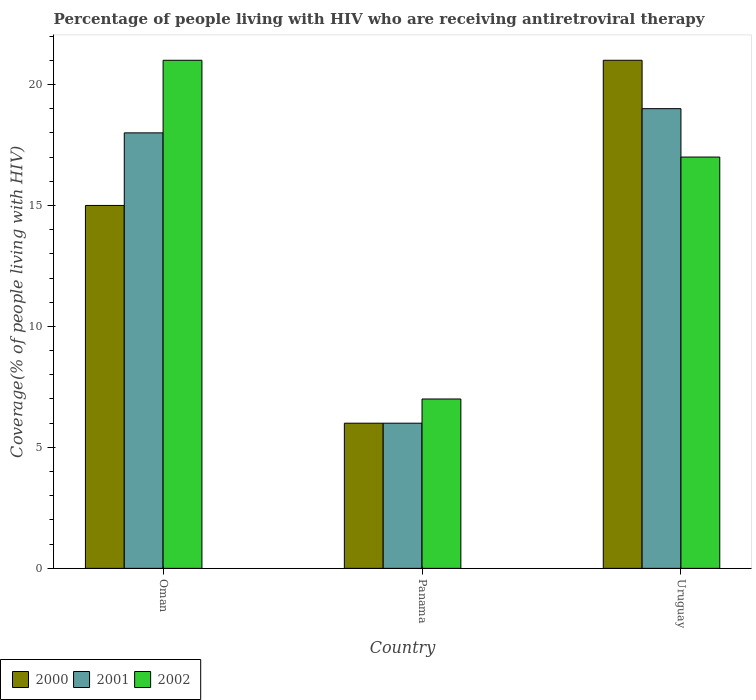Are the number of bars per tick equal to the number of legend labels?
Your response must be concise. Yes. How many bars are there on the 3rd tick from the left?
Offer a terse response. 3. What is the label of the 1st group of bars from the left?
Provide a succinct answer. Oman. In how many cases, is the number of bars for a given country not equal to the number of legend labels?
Your response must be concise. 0. Across all countries, what is the maximum percentage of the HIV infected people who are receiving antiretroviral therapy in 2000?
Offer a very short reply. 21. In which country was the percentage of the HIV infected people who are receiving antiretroviral therapy in 2000 maximum?
Your answer should be very brief. Uruguay. In which country was the percentage of the HIV infected people who are receiving antiretroviral therapy in 2000 minimum?
Offer a very short reply. Panama. What is the difference between the percentage of the HIV infected people who are receiving antiretroviral therapy in 2001 in Uruguay and the percentage of the HIV infected people who are receiving antiretroviral therapy in 2000 in Panama?
Give a very brief answer. 13. What is the average percentage of the HIV infected people who are receiving antiretroviral therapy in 2001 per country?
Give a very brief answer. 14.33. What is the ratio of the percentage of the HIV infected people who are receiving antiretroviral therapy in 2002 in Panama to that in Uruguay?
Offer a terse response. 0.41. Is the percentage of the HIV infected people who are receiving antiretroviral therapy in 2001 in Oman less than that in Panama?
Provide a succinct answer. No. Is the difference between the percentage of the HIV infected people who are receiving antiretroviral therapy in 2001 in Oman and Uruguay greater than the difference between the percentage of the HIV infected people who are receiving antiretroviral therapy in 2000 in Oman and Uruguay?
Offer a very short reply. Yes. What is the difference between the highest and the second highest percentage of the HIV infected people who are receiving antiretroviral therapy in 2001?
Provide a succinct answer. -1. What is the difference between the highest and the lowest percentage of the HIV infected people who are receiving antiretroviral therapy in 2001?
Offer a terse response. 13. In how many countries, is the percentage of the HIV infected people who are receiving antiretroviral therapy in 2000 greater than the average percentage of the HIV infected people who are receiving antiretroviral therapy in 2000 taken over all countries?
Offer a very short reply. 2. Is the sum of the percentage of the HIV infected people who are receiving antiretroviral therapy in 2002 in Oman and Panama greater than the maximum percentage of the HIV infected people who are receiving antiretroviral therapy in 2001 across all countries?
Your answer should be very brief. Yes. What does the 2nd bar from the left in Uruguay represents?
Your answer should be compact. 2001. Are all the bars in the graph horizontal?
Provide a succinct answer. No. How many countries are there in the graph?
Your answer should be very brief. 3. Does the graph contain any zero values?
Offer a very short reply. No. Does the graph contain grids?
Your response must be concise. No. How many legend labels are there?
Give a very brief answer. 3. What is the title of the graph?
Keep it short and to the point. Percentage of people living with HIV who are receiving antiretroviral therapy. What is the label or title of the Y-axis?
Your response must be concise. Coverage(% of people living with HIV). What is the Coverage(% of people living with HIV) of 2000 in Oman?
Ensure brevity in your answer.  15. What is the Coverage(% of people living with HIV) of 2002 in Oman?
Give a very brief answer. 21. What is the Coverage(% of people living with HIV) of 2002 in Panama?
Give a very brief answer. 7. What is the Coverage(% of people living with HIV) of 2002 in Uruguay?
Keep it short and to the point. 17. Across all countries, what is the maximum Coverage(% of people living with HIV) in 2001?
Offer a very short reply. 19. Across all countries, what is the minimum Coverage(% of people living with HIV) of 2002?
Keep it short and to the point. 7. What is the total Coverage(% of people living with HIV) in 2002 in the graph?
Provide a succinct answer. 45. What is the difference between the Coverage(% of people living with HIV) of 2000 in Oman and that in Panama?
Your response must be concise. 9. What is the difference between the Coverage(% of people living with HIV) of 2001 in Oman and that in Panama?
Give a very brief answer. 12. What is the difference between the Coverage(% of people living with HIV) of 2000 in Oman and that in Uruguay?
Make the answer very short. -6. What is the difference between the Coverage(% of people living with HIV) of 2002 in Oman and that in Uruguay?
Provide a succinct answer. 4. What is the difference between the Coverage(% of people living with HIV) in 2000 in Panama and that in Uruguay?
Provide a succinct answer. -15. What is the difference between the Coverage(% of people living with HIV) of 2001 in Panama and that in Uruguay?
Ensure brevity in your answer.  -13. What is the difference between the Coverage(% of people living with HIV) in 2000 in Oman and the Coverage(% of people living with HIV) in 2001 in Panama?
Give a very brief answer. 9. What is the difference between the Coverage(% of people living with HIV) of 2000 in Oman and the Coverage(% of people living with HIV) of 2002 in Panama?
Your answer should be very brief. 8. What is the difference between the Coverage(% of people living with HIV) of 2001 in Oman and the Coverage(% of people living with HIV) of 2002 in Panama?
Provide a short and direct response. 11. What is the difference between the Coverage(% of people living with HIV) of 2000 in Panama and the Coverage(% of people living with HIV) of 2001 in Uruguay?
Keep it short and to the point. -13. What is the difference between the Coverage(% of people living with HIV) in 2000 in Panama and the Coverage(% of people living with HIV) in 2002 in Uruguay?
Your answer should be very brief. -11. What is the difference between the Coverage(% of people living with HIV) in 2001 in Panama and the Coverage(% of people living with HIV) in 2002 in Uruguay?
Keep it short and to the point. -11. What is the average Coverage(% of people living with HIV) of 2000 per country?
Provide a succinct answer. 14. What is the average Coverage(% of people living with HIV) of 2001 per country?
Your answer should be very brief. 14.33. What is the average Coverage(% of people living with HIV) of 2002 per country?
Provide a succinct answer. 15. What is the difference between the Coverage(% of people living with HIV) of 2000 and Coverage(% of people living with HIV) of 2002 in Oman?
Ensure brevity in your answer.  -6. What is the difference between the Coverage(% of people living with HIV) of 2000 and Coverage(% of people living with HIV) of 2001 in Panama?
Give a very brief answer. 0. What is the difference between the Coverage(% of people living with HIV) in 2001 and Coverage(% of people living with HIV) in 2002 in Panama?
Your response must be concise. -1. What is the difference between the Coverage(% of people living with HIV) in 2000 and Coverage(% of people living with HIV) in 2001 in Uruguay?
Offer a terse response. 2. What is the difference between the Coverage(% of people living with HIV) of 2000 and Coverage(% of people living with HIV) of 2002 in Uruguay?
Provide a short and direct response. 4. What is the difference between the Coverage(% of people living with HIV) in 2001 and Coverage(% of people living with HIV) in 2002 in Uruguay?
Your response must be concise. 2. What is the ratio of the Coverage(% of people living with HIV) in 2001 in Oman to that in Panama?
Your response must be concise. 3. What is the ratio of the Coverage(% of people living with HIV) in 2001 in Oman to that in Uruguay?
Ensure brevity in your answer.  0.95. What is the ratio of the Coverage(% of people living with HIV) in 2002 in Oman to that in Uruguay?
Offer a very short reply. 1.24. What is the ratio of the Coverage(% of people living with HIV) in 2000 in Panama to that in Uruguay?
Your response must be concise. 0.29. What is the ratio of the Coverage(% of people living with HIV) of 2001 in Panama to that in Uruguay?
Offer a terse response. 0.32. What is the ratio of the Coverage(% of people living with HIV) in 2002 in Panama to that in Uruguay?
Give a very brief answer. 0.41. What is the difference between the highest and the second highest Coverage(% of people living with HIV) of 2000?
Provide a succinct answer. 6. What is the difference between the highest and the second highest Coverage(% of people living with HIV) of 2002?
Provide a short and direct response. 4. What is the difference between the highest and the lowest Coverage(% of people living with HIV) of 2000?
Give a very brief answer. 15. What is the difference between the highest and the lowest Coverage(% of people living with HIV) of 2002?
Provide a short and direct response. 14. 